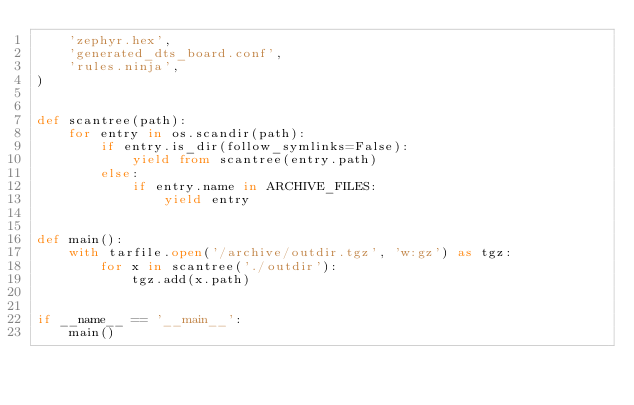<code> <loc_0><loc_0><loc_500><loc_500><_Python_>    'zephyr.hex',
    'generated_dts_board.conf',
    'rules.ninja',
)


def scantree(path):
    for entry in os.scandir(path):
        if entry.is_dir(follow_symlinks=False):
            yield from scantree(entry.path)
        else:
            if entry.name in ARCHIVE_FILES:
                yield entry


def main():
    with tarfile.open('/archive/outdir.tgz', 'w:gz') as tgz:
        for x in scantree('./outdir'):
            tgz.add(x.path)


if __name__ == '__main__':
    main()
</code> 